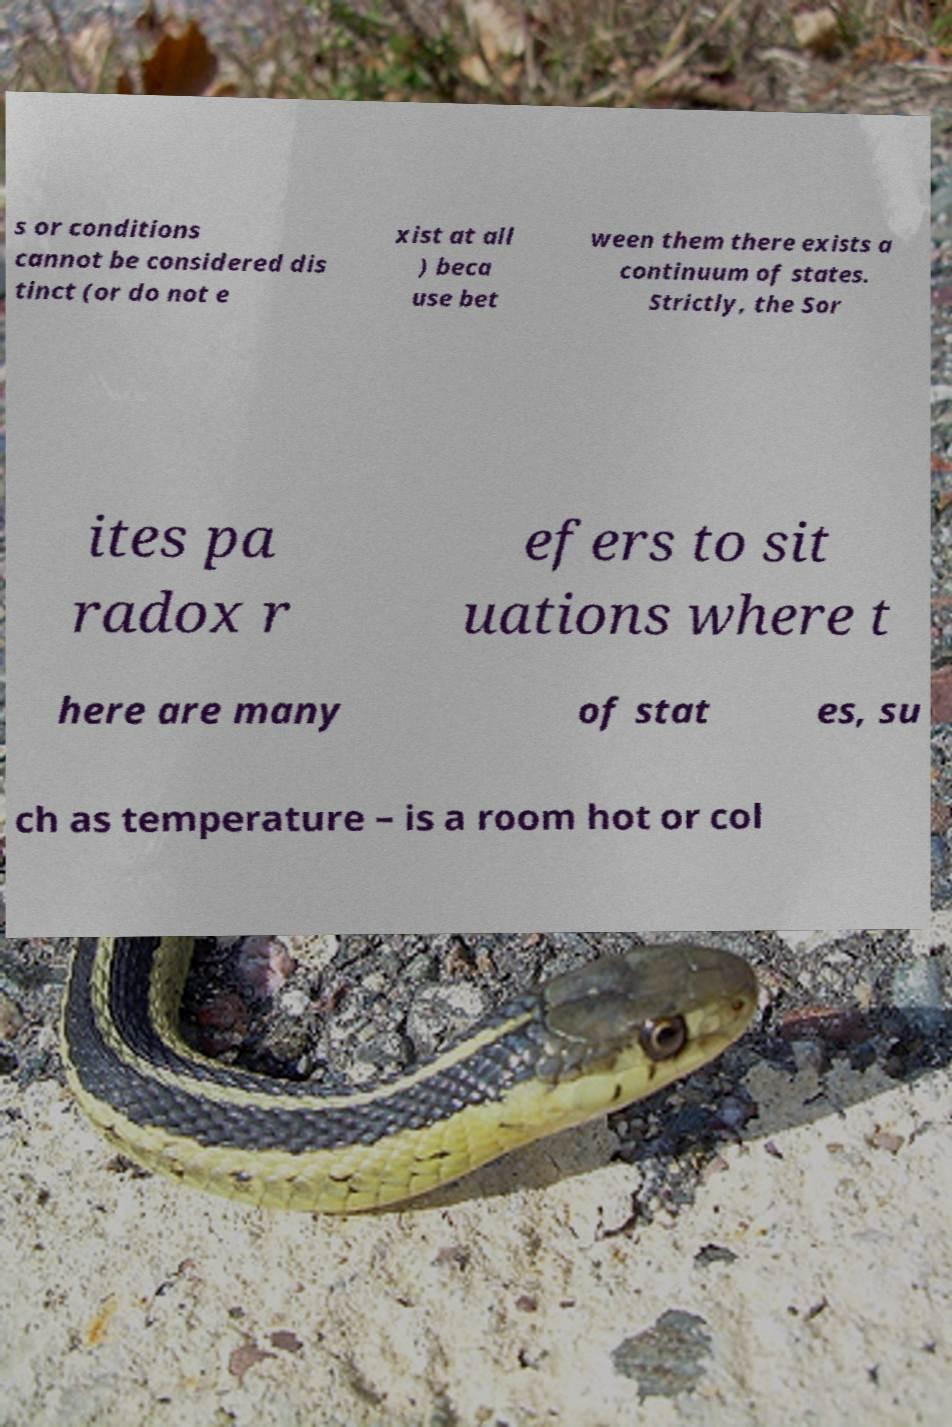Please identify and transcribe the text found in this image. s or conditions cannot be considered dis tinct (or do not e xist at all ) beca use bet ween them there exists a continuum of states. Strictly, the Sor ites pa radox r efers to sit uations where t here are many of stat es, su ch as temperature – is a room hot or col 